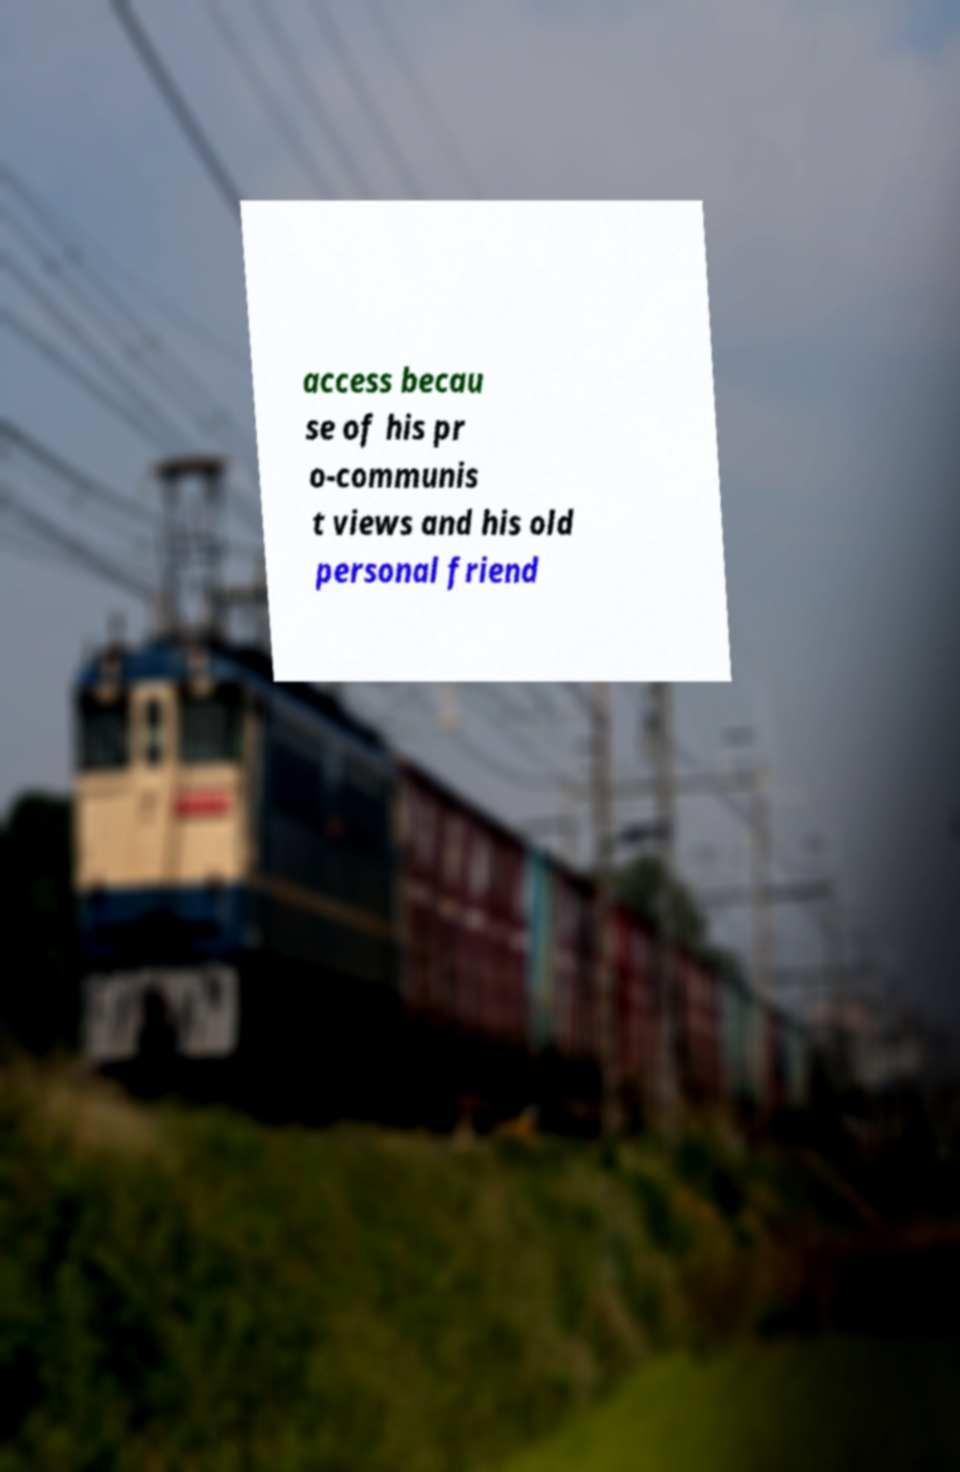Please identify and transcribe the text found in this image. access becau se of his pr o-communis t views and his old personal friend 